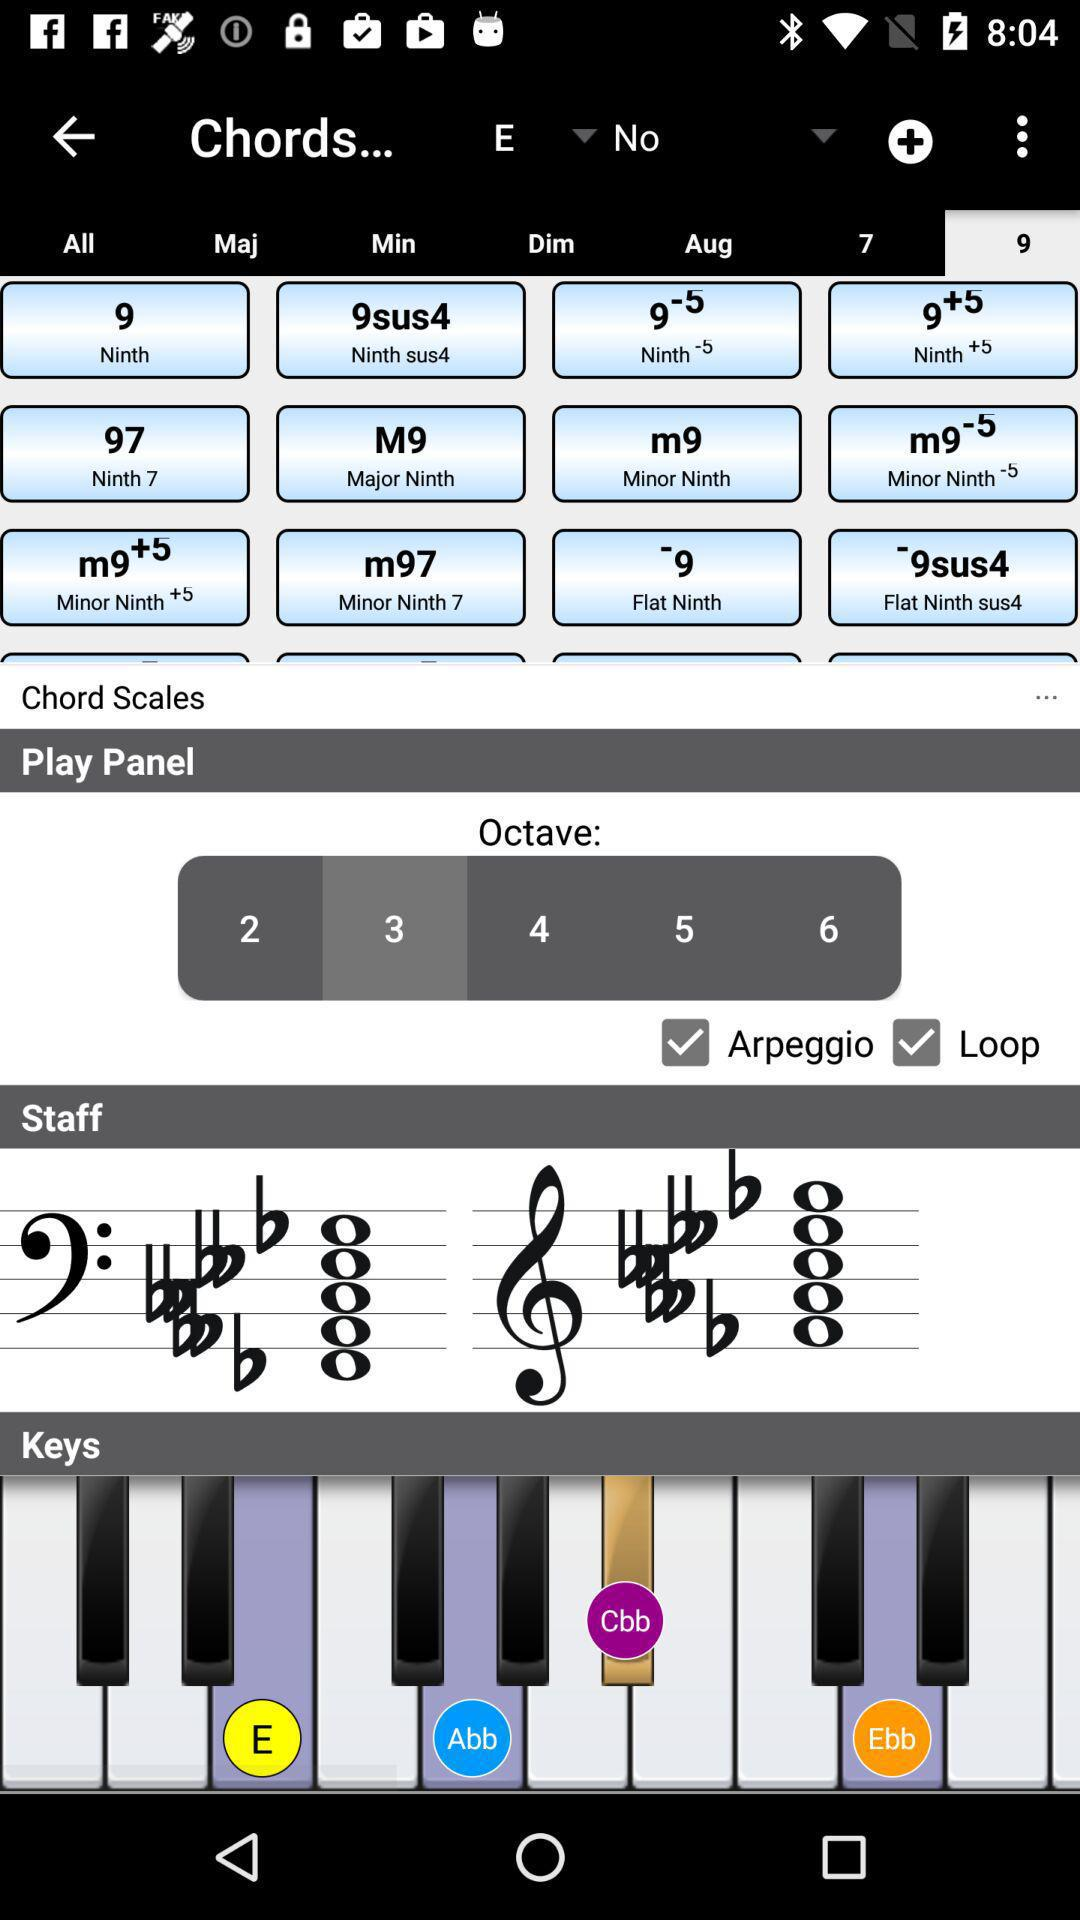Which tab is selected? The selected tab is "9". 